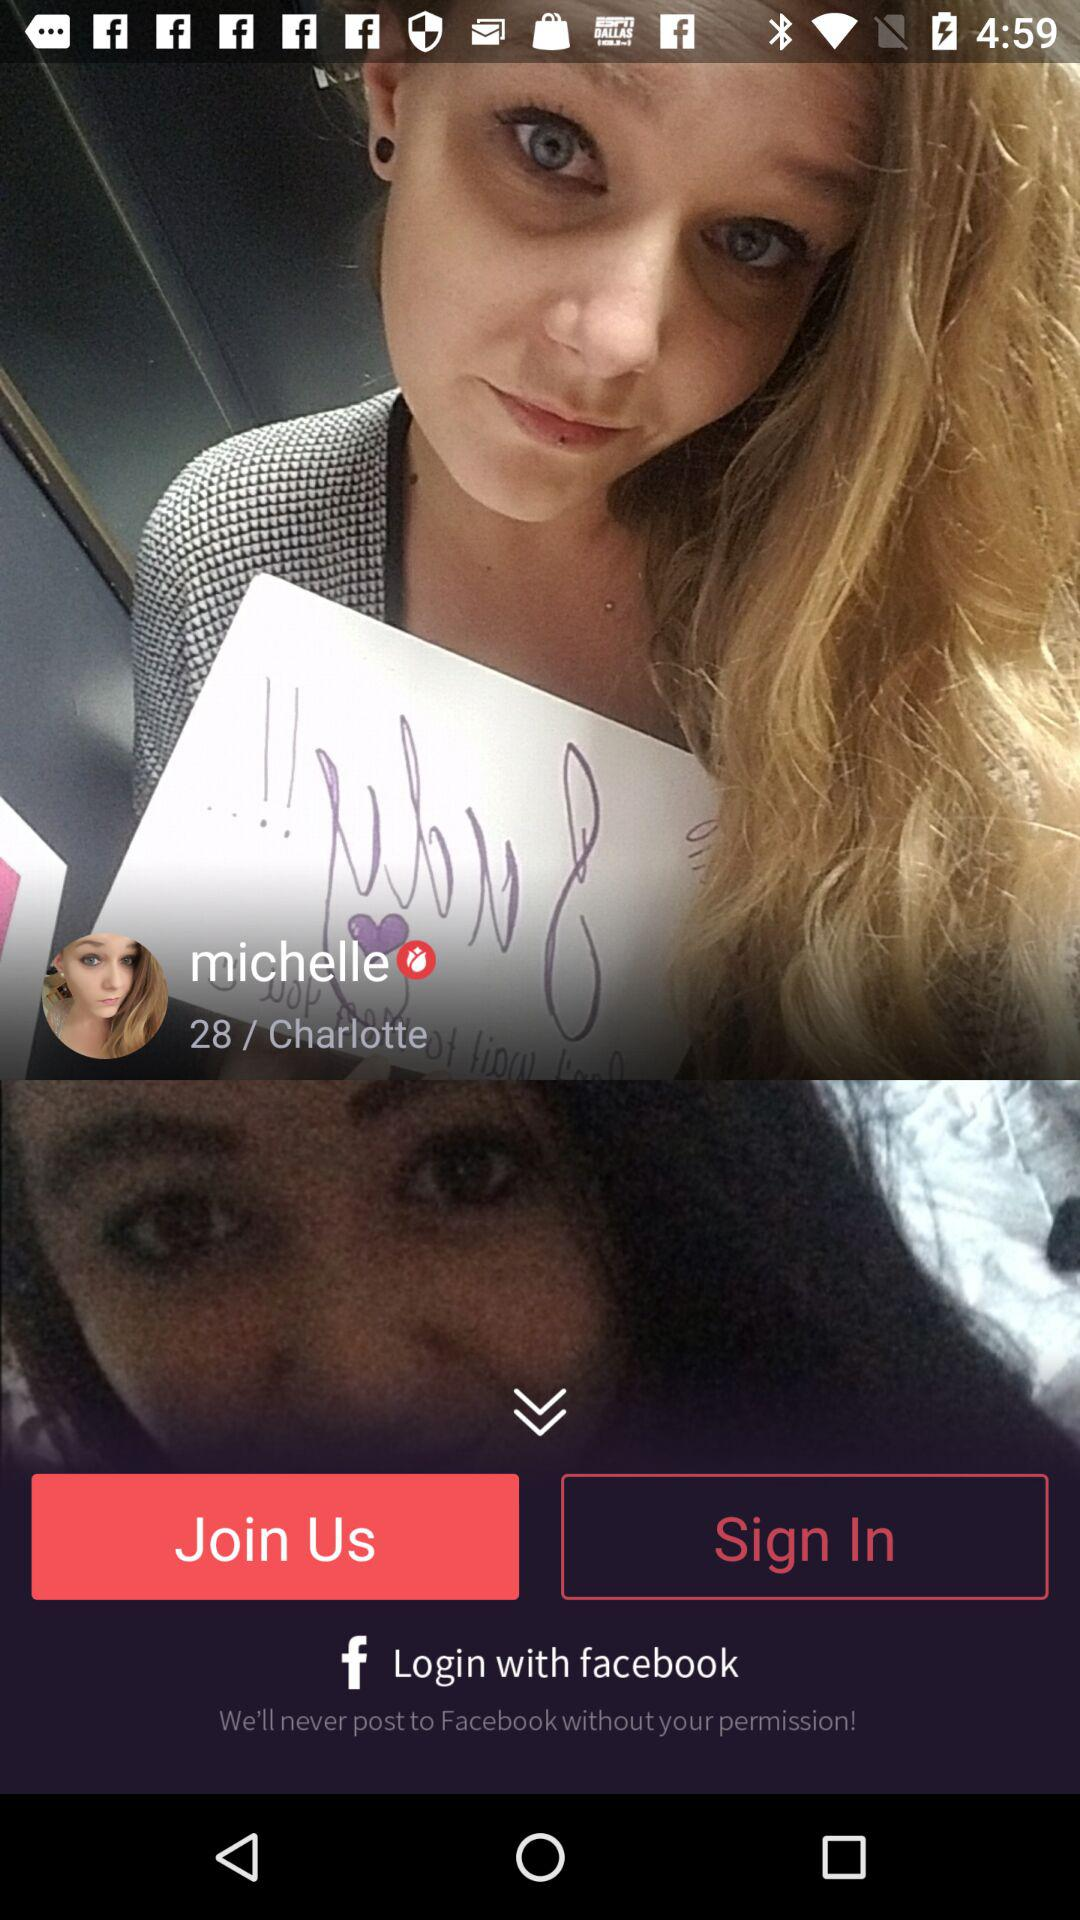From where Michelle belongs? Michelle belongs to Charlotte. 